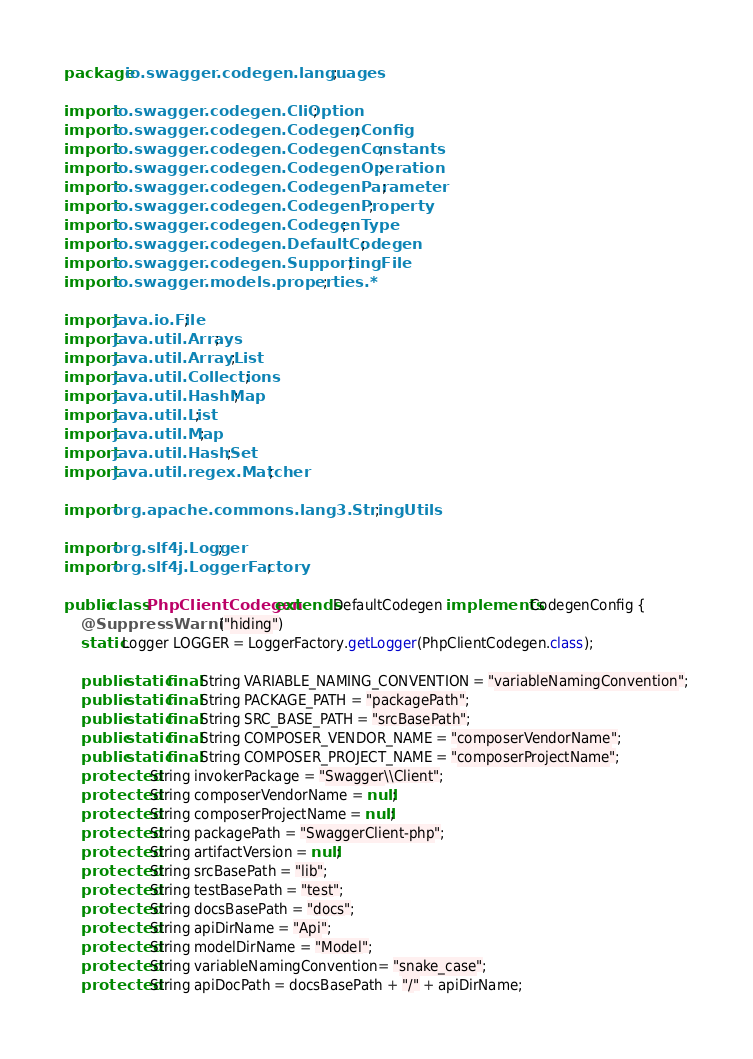<code> <loc_0><loc_0><loc_500><loc_500><_Java_>package io.swagger.codegen.languages;

import io.swagger.codegen.CliOption;
import io.swagger.codegen.CodegenConfig;
import io.swagger.codegen.CodegenConstants;
import io.swagger.codegen.CodegenOperation;
import io.swagger.codegen.CodegenParameter;
import io.swagger.codegen.CodegenProperty;
import io.swagger.codegen.CodegenType;
import io.swagger.codegen.DefaultCodegen;
import io.swagger.codegen.SupportingFile;
import io.swagger.models.properties.*;

import java.io.File;
import java.util.Arrays;
import java.util.ArrayList;
import java.util.Collections;
import java.util.HashMap;
import java.util.List;
import java.util.Map;
import java.util.HashSet;
import java.util.regex.Matcher;

import org.apache.commons.lang3.StringUtils;

import org.slf4j.Logger;
import org.slf4j.LoggerFactory;

public class PhpClientCodegen extends DefaultCodegen implements CodegenConfig {
    @SuppressWarnings("hiding")
    static Logger LOGGER = LoggerFactory.getLogger(PhpClientCodegen.class);

    public static final String VARIABLE_NAMING_CONVENTION = "variableNamingConvention";
    public static final String PACKAGE_PATH = "packagePath";
    public static final String SRC_BASE_PATH = "srcBasePath";
    public static final String COMPOSER_VENDOR_NAME = "composerVendorName";
    public static final String COMPOSER_PROJECT_NAME = "composerProjectName";
    protected String invokerPackage = "Swagger\\Client";
    protected String composerVendorName = null;
    protected String composerProjectName = null;
    protected String packagePath = "SwaggerClient-php";
    protected String artifactVersion = null;
    protected String srcBasePath = "lib";
    protected String testBasePath = "test";
    protected String docsBasePath = "docs";
    protected String apiDirName = "Api";
    protected String modelDirName = "Model";
    protected String variableNamingConvention= "snake_case";
    protected String apiDocPath = docsBasePath + "/" + apiDirName;</code> 